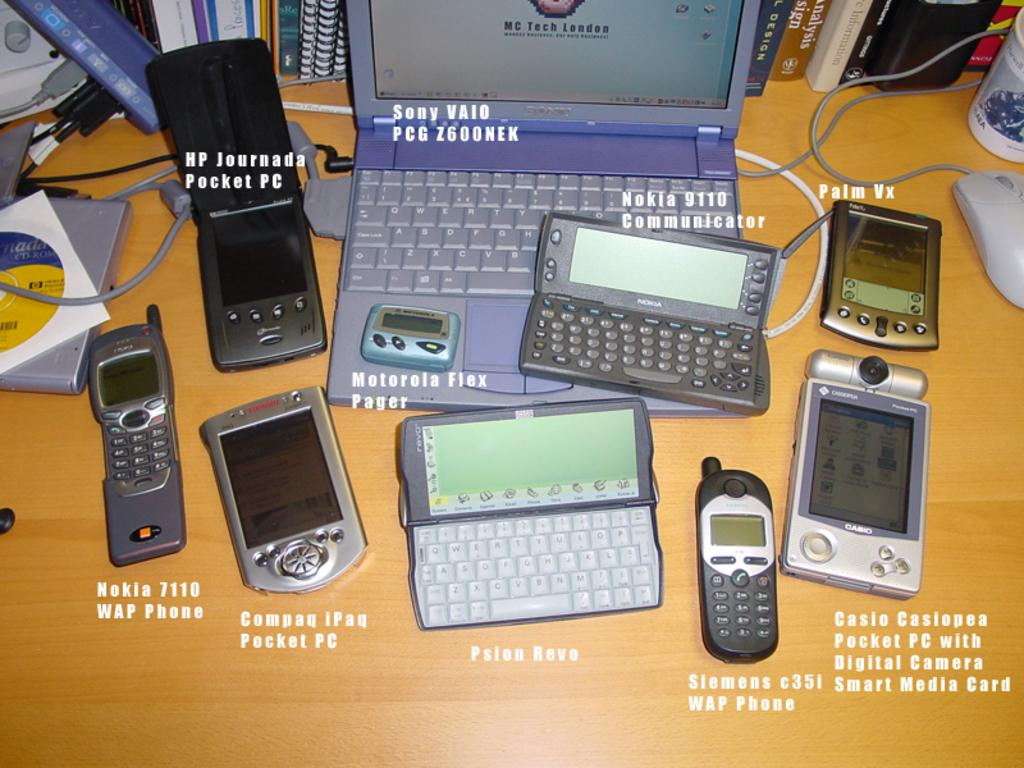<image>
Share a concise interpretation of the image provided. Old electronics sit on a table including some by Nokia and Sony. 